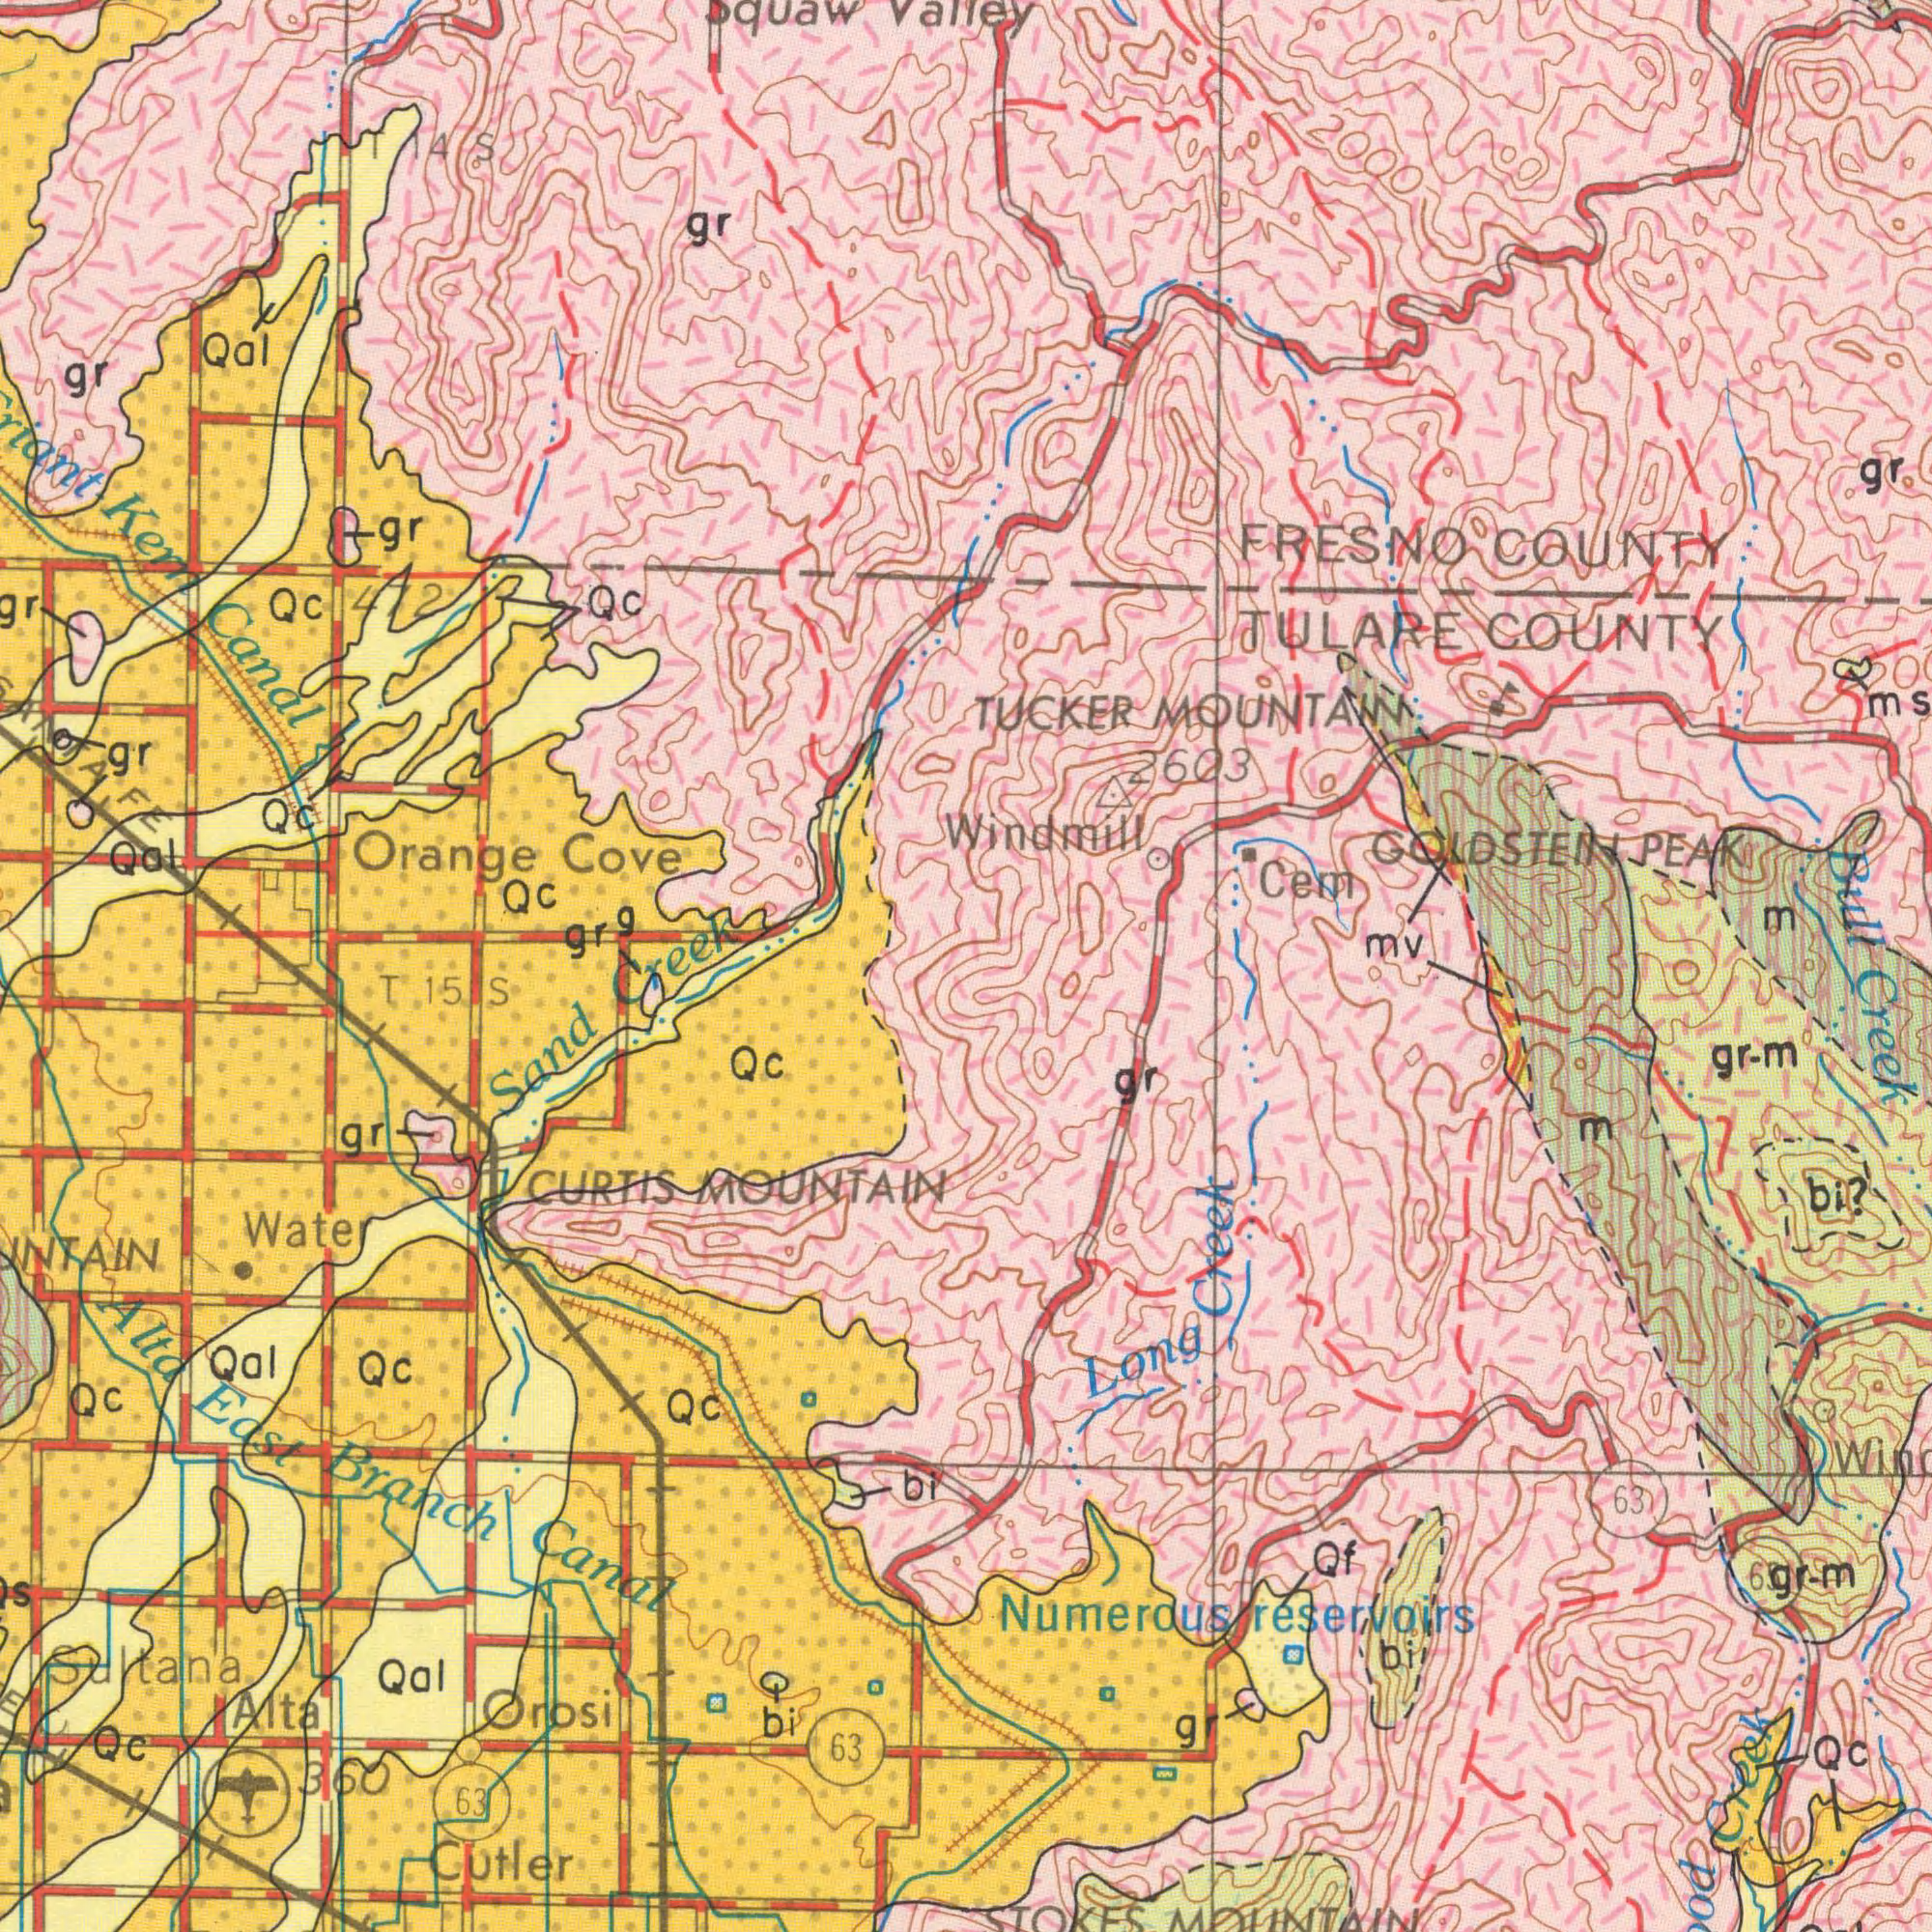What text can you see in the top-right section? TUCKER MOUNTAIN 2603 FRESNO COUNTY TULARE COUNTY Cem gr GOLDSTEIN PEAK mv Windmill ms 2000 Bull m What text appears in the top-left area of the image? Kem Canal Orange Cove Qal Qc gr Qal gr Qc grg Qc gr gr Qc Squaw Valley 472 gr 4S Creek What text can you see in the bottom-left section? Alta East Branch Canal Sand CURTIS MOUNTAIN Orosi Cutler Qc 63 Water Qal Alta Qal Qc Qc Qc bi gr Qc Sultana bi 63 360 T 15 S What text appears in the bottom-right area of the image? Numerous reservoirs Long Creek bi? Creek gr-m Qf gr-m 63 Qc bi gr STOKES MOUNTAIN gr m Creek 65 